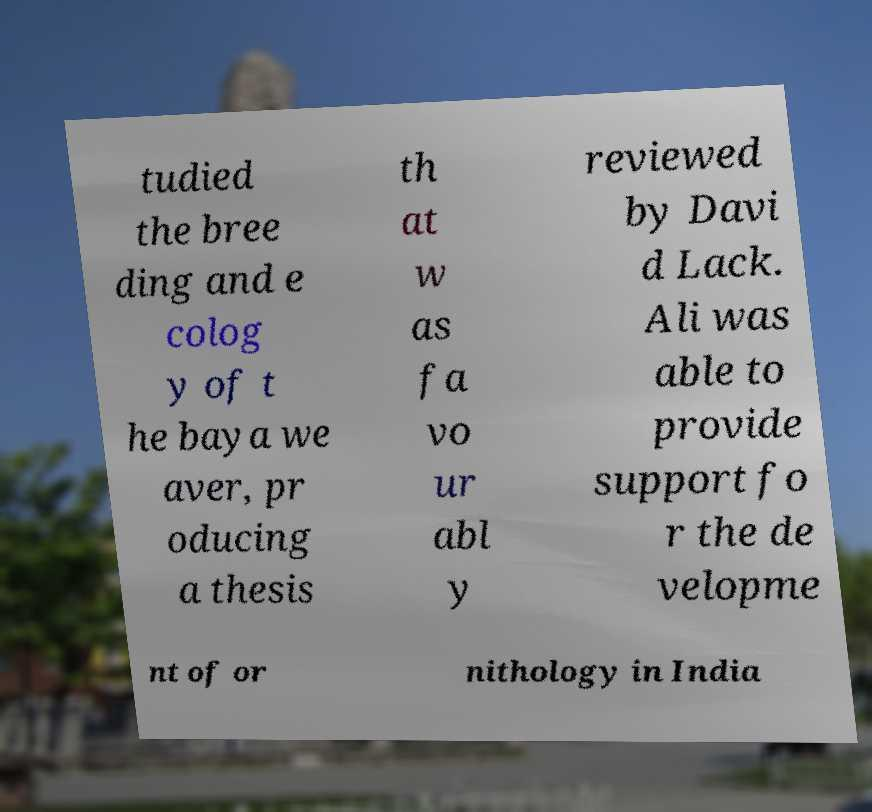Can you accurately transcribe the text from the provided image for me? tudied the bree ding and e colog y of t he baya we aver, pr oducing a thesis th at w as fa vo ur abl y reviewed by Davi d Lack. Ali was able to provide support fo r the de velopme nt of or nithology in India 